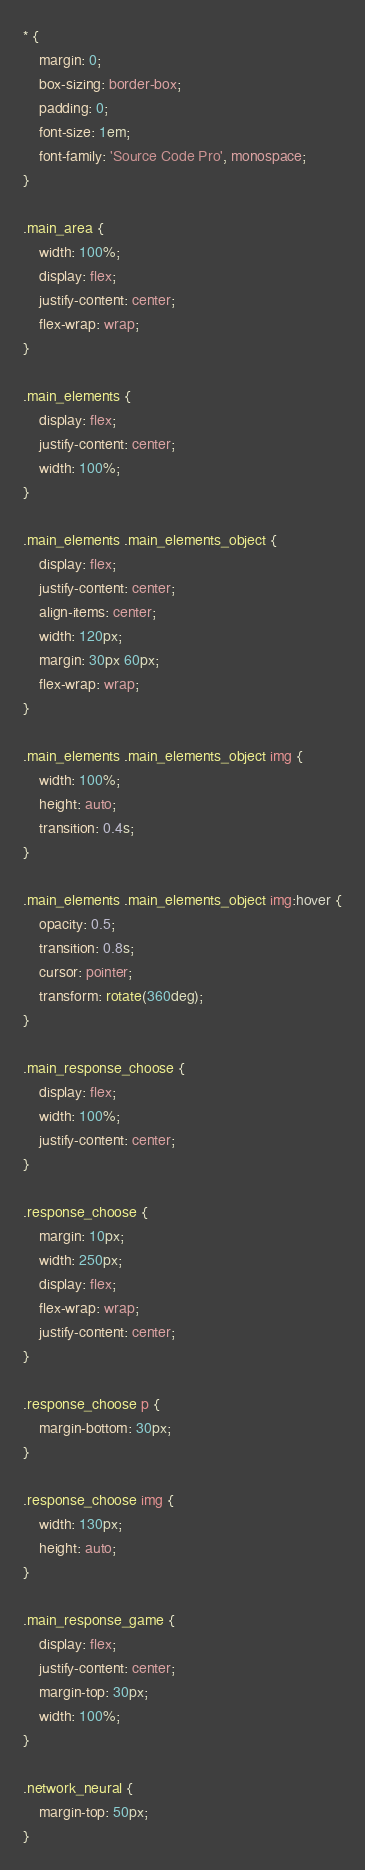<code> <loc_0><loc_0><loc_500><loc_500><_CSS_>* {
    margin: 0;
    box-sizing: border-box;
    padding: 0;
    font-size: 1em;
    font-family: 'Source Code Pro', monospace;
}

.main_area {
    width: 100%;
    display: flex;
    justify-content: center;
    flex-wrap: wrap;
}

.main_elements {
    display: flex;
    justify-content: center;
    width: 100%;
}

.main_elements .main_elements_object {
    display: flex;
    justify-content: center;
    align-items: center;
    width: 120px;
    margin: 30px 60px;
    flex-wrap: wrap;
}

.main_elements .main_elements_object img {
    width: 100%;
    height: auto;
    transition: 0.4s;
}

.main_elements .main_elements_object img:hover {
    opacity: 0.5;
    transition: 0.8s;
    cursor: pointer;
    transform: rotate(360deg);
}

.main_response_choose {
    display: flex;
    width: 100%;
    justify-content: center;
}

.response_choose {
    margin: 10px;
    width: 250px;
    display: flex;
    flex-wrap: wrap;
    justify-content: center;
}

.response_choose p {
    margin-bottom: 30px;
}

.response_choose img {
    width: 130px;
    height: auto;
}

.main_response_game {
    display: flex;
    justify-content: center;
    margin-top: 30px;
    width: 100%;
}

.network_neural {
    margin-top: 50px;
}
</code> 